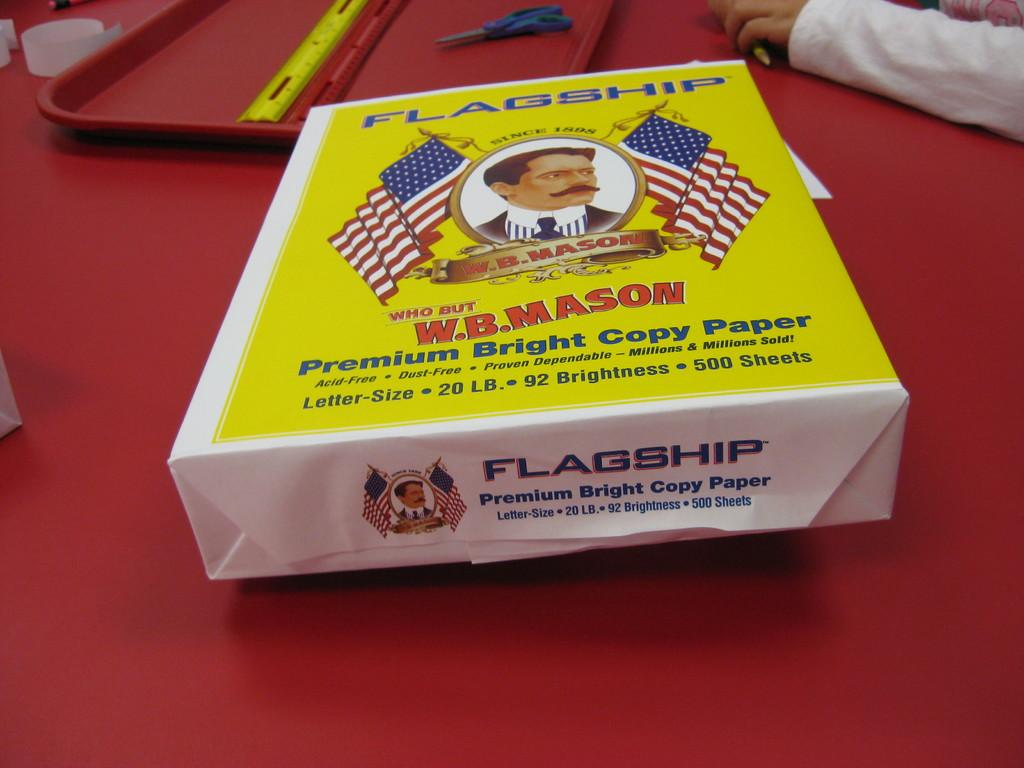<image>
Describe the image concisely. A ream of Flagship paper lays on a red table. 